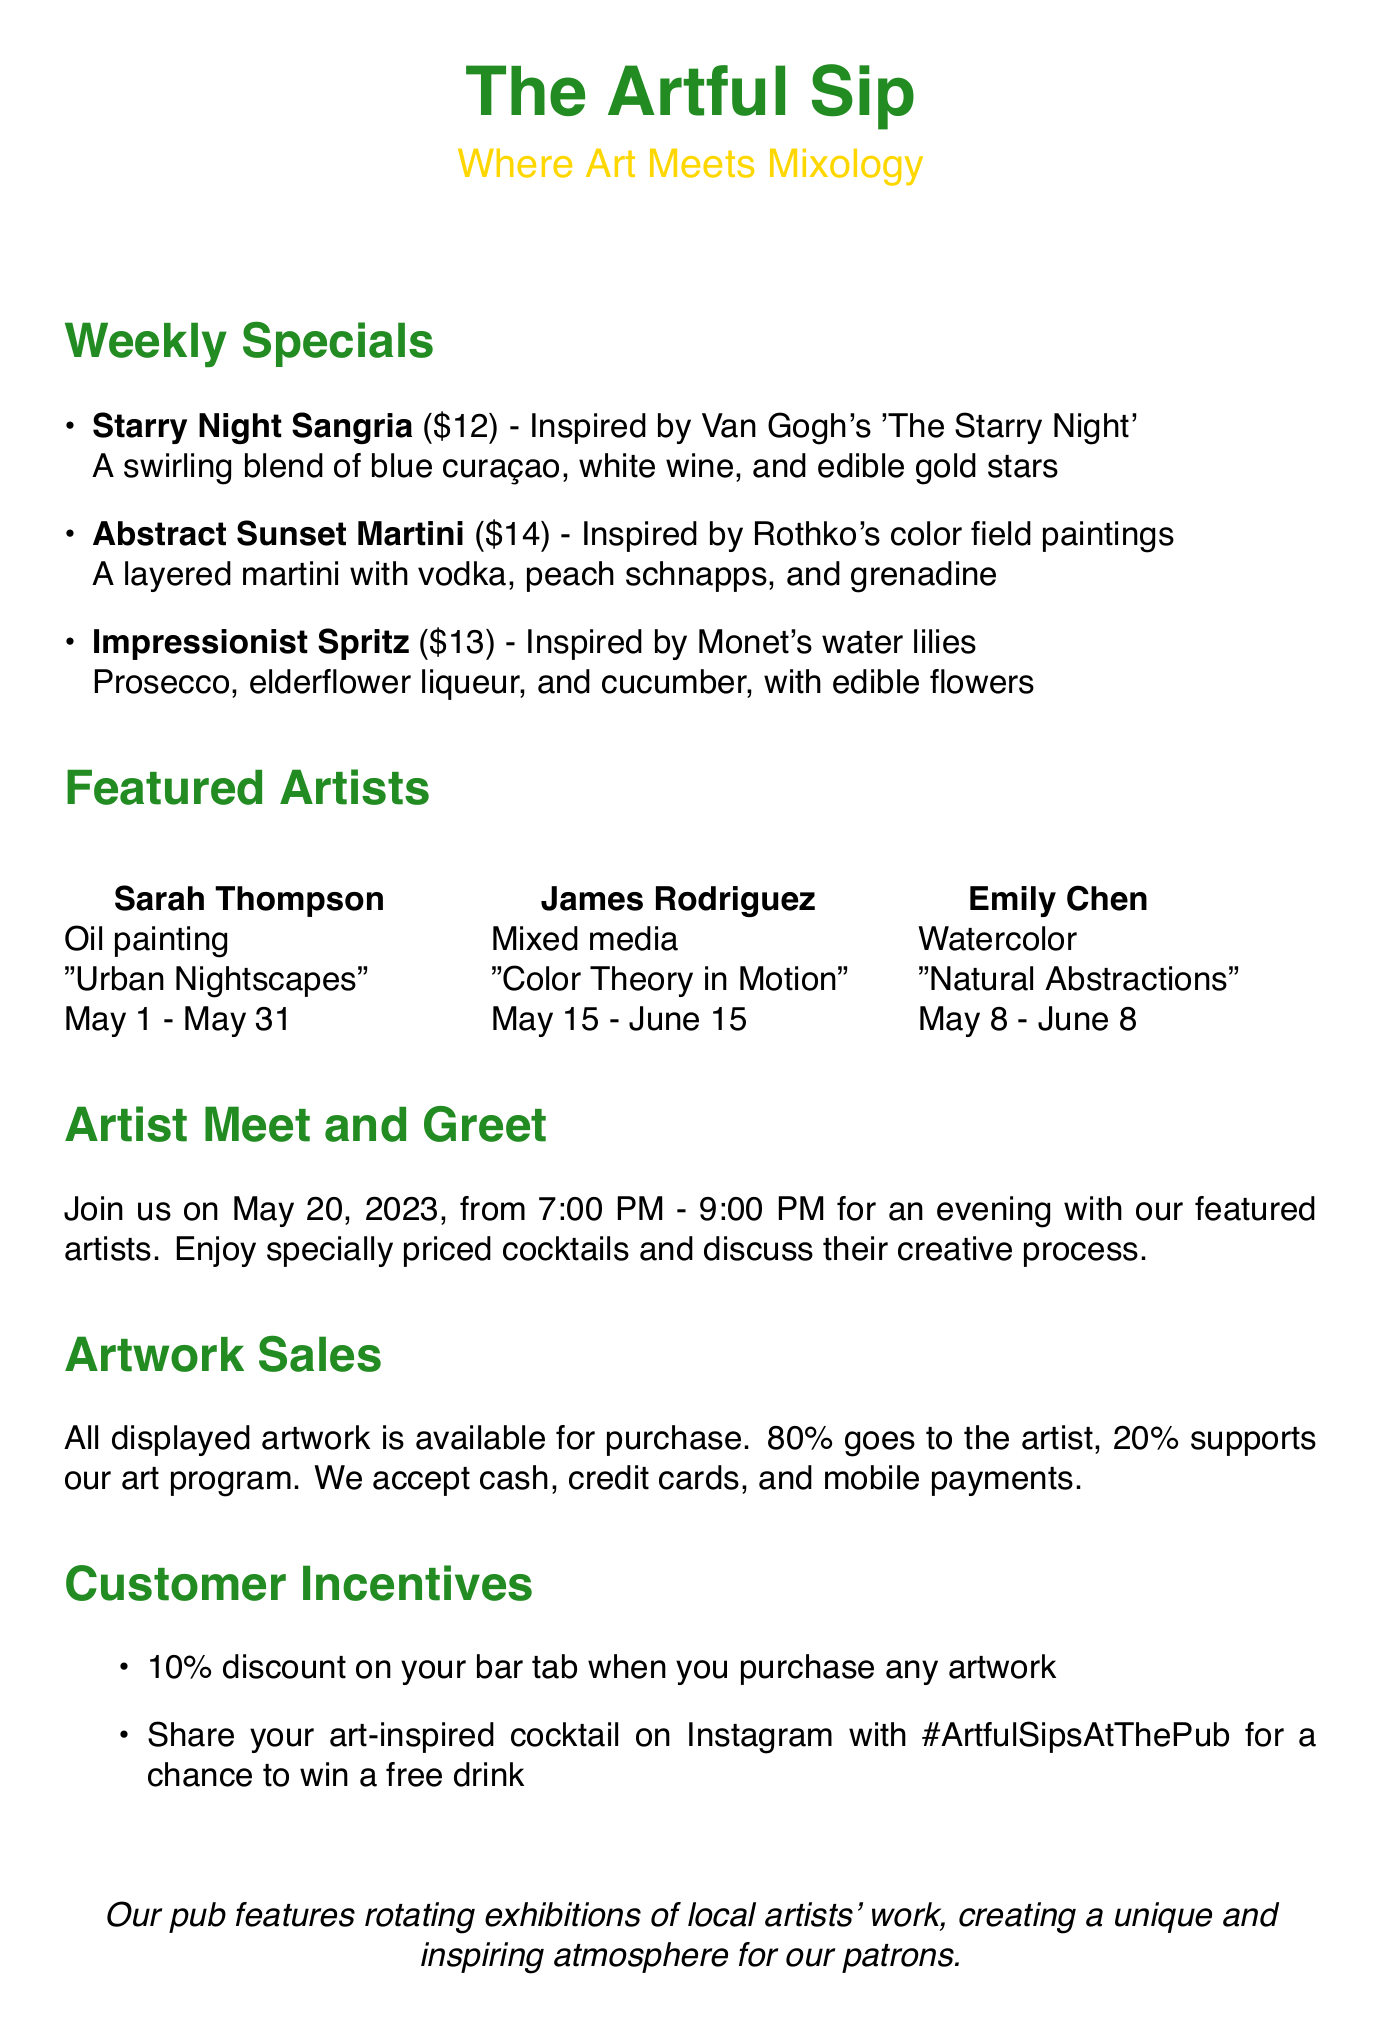What is the name of the first cocktail? The name of the first cocktail is listed as "Starry Night Sangria".
Answer: Starry Night Sangria Who is the artist behind the "Abstract Sunset Martini"? This cocktail is inspired by the work of artist James Rodriguez.
Answer: James Rodriguez What is the price of "Impressionist Spritz"? The document states the price for this cocktail is $13.
Answer: $13 When is the artist meet and greet event scheduled? The document specifies that the event is on May 20, 2023.
Answer: May 20, 2023 What percentage of the artwork sale price goes to the artist? The document mentions that 80% of the sale price goes directly to the artist.
Answer: 80% What type of artwork does Sarah Thompson create? The document indicates that Sarah Thompson works in oil painting.
Answer: Oil painting What is the exhibit duration for James Rodriguez? This artist's exhibit runs from May 15 to June 15, as mentioned in the document.
Answer: May 15 - June 15 What discount do customers receive on their bar tab for purchasing artwork? The document states customers receive a 10% discount on their bar tab.
Answer: 10% What is the medium of Emily Chen's artwork? According to the document, Emily Chen's medium is watercolor.
Answer: Watercolor 